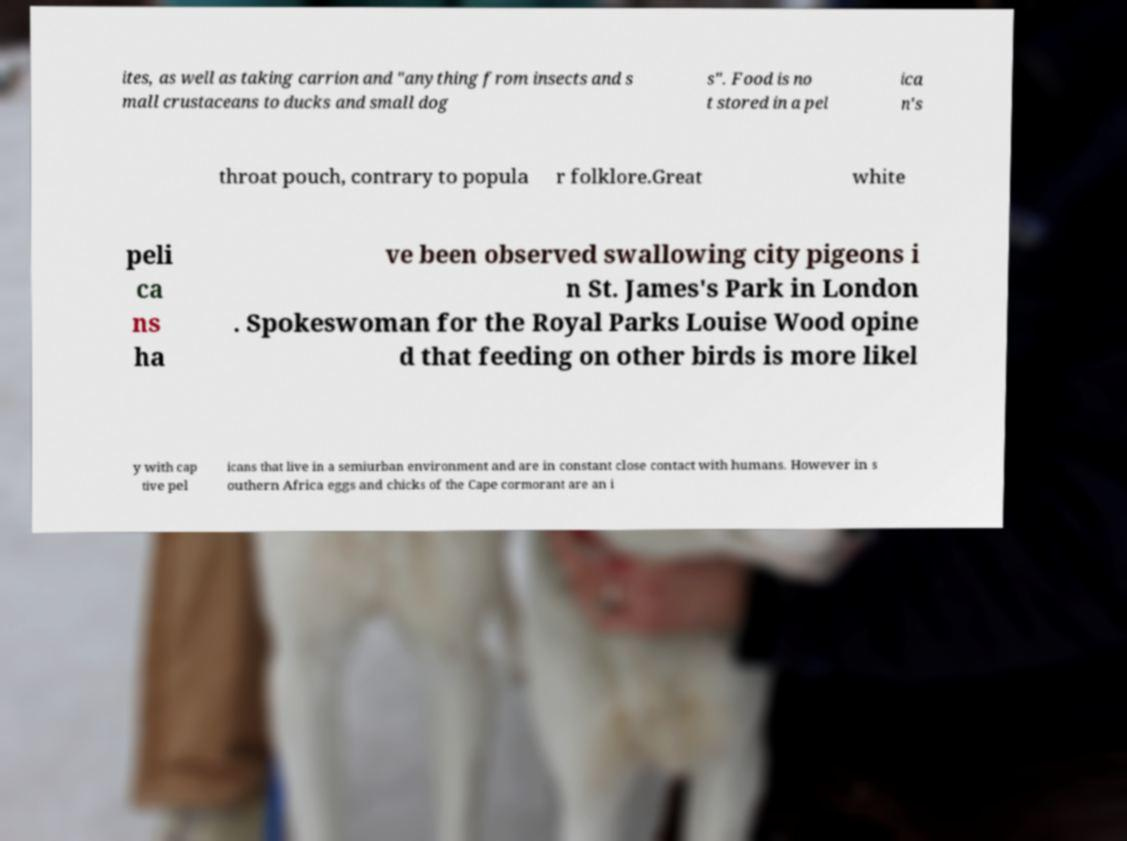For documentation purposes, I need the text within this image transcribed. Could you provide that? ites, as well as taking carrion and "anything from insects and s mall crustaceans to ducks and small dog s". Food is no t stored in a pel ica n's throat pouch, contrary to popula r folklore.Great white peli ca ns ha ve been observed swallowing city pigeons i n St. James's Park in London . Spokeswoman for the Royal Parks Louise Wood opine d that feeding on other birds is more likel y with cap tive pel icans that live in a semiurban environment and are in constant close contact with humans. However in s outhern Africa eggs and chicks of the Cape cormorant are an i 